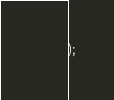<code> <loc_0><loc_0><loc_500><loc_500><_SQL_>);
</code> 